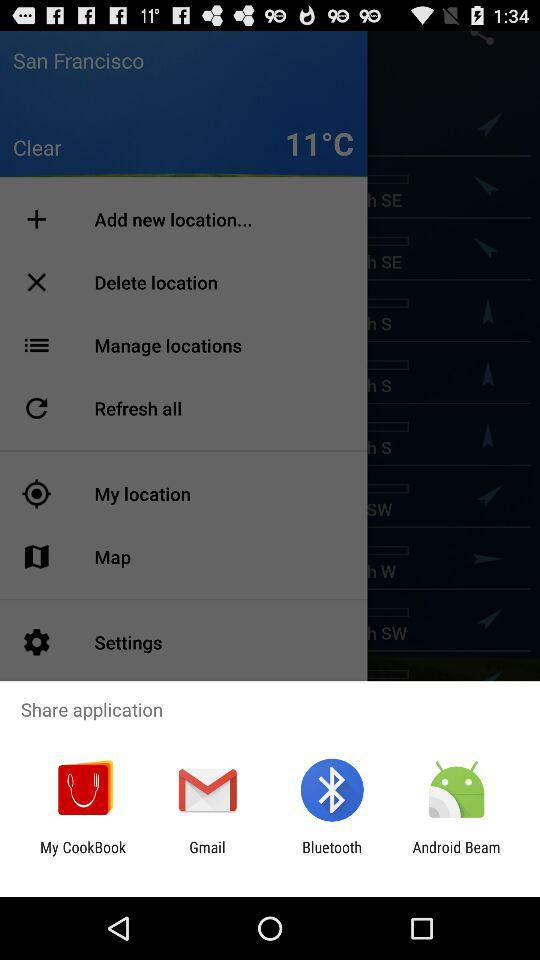What app can I use to share the application? You can use "My CookBook", "Gmail", "Bluetooth", and "Android Beam". 